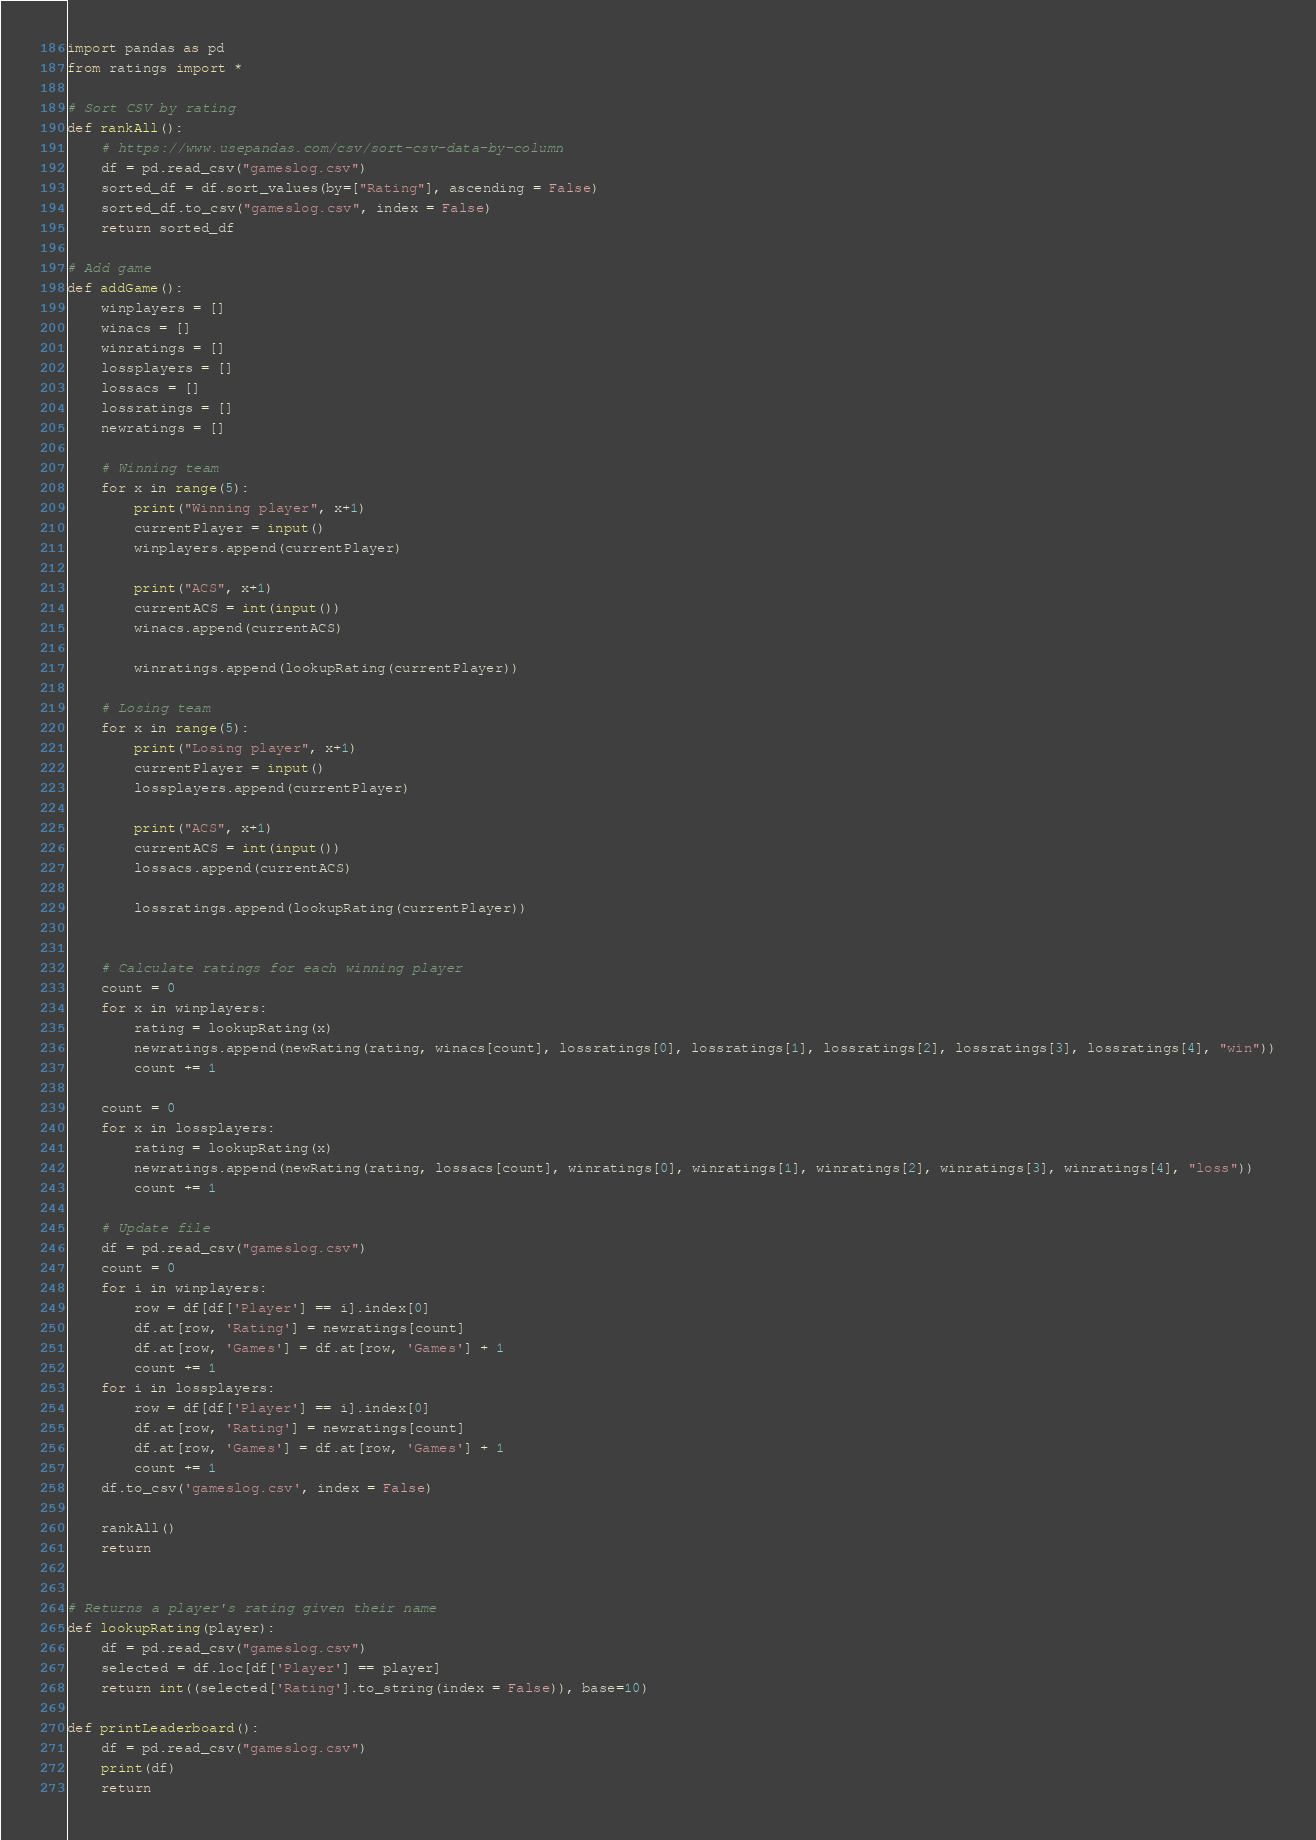<code> <loc_0><loc_0><loc_500><loc_500><_Python_>import pandas as pd
from ratings import *

# Sort CSV by rating
def rankAll():
    # https://www.usepandas.com/csv/sort-csv-data-by-column
    df = pd.read_csv("gameslog.csv")
    sorted_df = df.sort_values(by=["Rating"], ascending = False)
    sorted_df.to_csv("gameslog.csv", index = False)
    return sorted_df
    
# Add game
def addGame():
    winplayers = []
    winacs = []
    winratings = []
    lossplayers = []
    lossacs = []
    lossratings = []
    newratings = []
    
    # Winning team
    for x in range(5):
        print("Winning player", x+1)
        currentPlayer = input()
        winplayers.append(currentPlayer)

        print("ACS", x+1)
        currentACS = int(input())
        winacs.append(currentACS)

        winratings.append(lookupRating(currentPlayer))

    # Losing team
    for x in range(5):
        print("Losing player", x+1)
        currentPlayer = input()
        lossplayers.append(currentPlayer)

        print("ACS", x+1)
        currentACS = int(input())
        lossacs.append(currentACS)

        lossratings.append(lookupRating(currentPlayer))

    
    # Calculate ratings for each winning player
    count = 0
    for x in winplayers:
        rating = lookupRating(x)
        newratings.append(newRating(rating, winacs[count], lossratings[0], lossratings[1], lossratings[2], lossratings[3], lossratings[4], "win"))
        count += 1
    
    count = 0
    for x in lossplayers:
        rating = lookupRating(x)
        newratings.append(newRating(rating, lossacs[count], winratings[0], winratings[1], winratings[2], winratings[3], winratings[4], "loss"))
        count += 1

    # Update file
    df = pd.read_csv("gameslog.csv")
    count = 0
    for i in winplayers:
        row = df[df['Player'] == i].index[0]
        df.at[row, 'Rating'] = newratings[count]
        df.at[row, 'Games'] = df.at[row, 'Games'] + 1
        count += 1
    for i in lossplayers:
        row = df[df['Player'] == i].index[0]
        df.at[row, 'Rating'] = newratings[count]
        df.at[row, 'Games'] = df.at[row, 'Games'] + 1
        count += 1
    df.to_csv('gameslog.csv', index = False)

    rankAll()
    return


# Returns a player's rating given their name
def lookupRating(player):
    df = pd.read_csv("gameslog.csv")
    selected = df.loc[df['Player'] == player]
    return int((selected['Rating'].to_string(index = False)), base=10)

def printLeaderboard():
    df = pd.read_csv("gameslog.csv")
    print(df)
    return</code> 